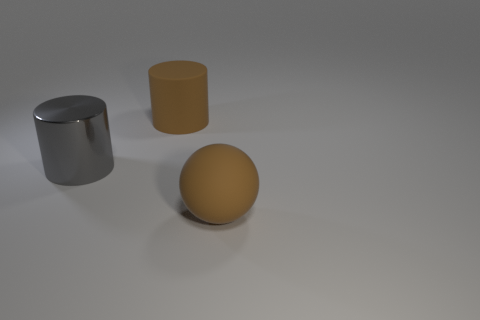The big object that is both in front of the large brown cylinder and right of the gray metallic cylinder is made of what material?
Your answer should be compact. Rubber. Does the large matte sphere have the same color as the big thing that is behind the gray shiny thing?
Provide a succinct answer. Yes. What is the material of the ball that is the same size as the brown cylinder?
Your response must be concise. Rubber. Are there any big brown cylinders made of the same material as the ball?
Your answer should be compact. Yes. How many purple metal blocks are there?
Offer a terse response. 0. Are the big brown sphere and the cylinder that is right of the large gray shiny cylinder made of the same material?
Keep it short and to the point. Yes. There is a object that is the same color as the matte cylinder; what is its material?
Provide a succinct answer. Rubber. How many big rubber cylinders are the same color as the big ball?
Give a very brief answer. 1. There is a gray shiny object; does it have the same shape as the brown object that is behind the large gray shiny object?
Offer a very short reply. Yes. What is the size of the brown rubber object behind the gray object?
Make the answer very short. Large. 